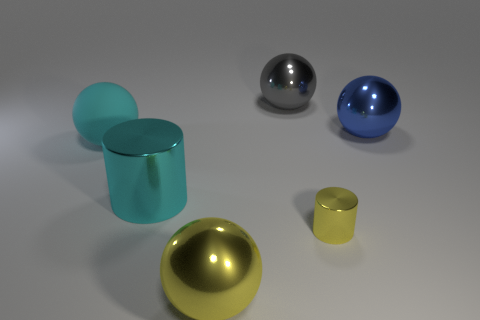Are there any other things that have the same size as the yellow cylinder?
Give a very brief answer. No. There is a metallic thing that is on the right side of the tiny yellow thing; does it have the same shape as the large cyan rubber object?
Offer a very short reply. Yes. Are there more cyan rubber things that are on the right side of the big yellow ball than small blue matte spheres?
Make the answer very short. No. There is a metallic cylinder to the left of the metallic sphere in front of the blue metallic sphere; what color is it?
Provide a succinct answer. Cyan. How many small yellow metal cylinders are there?
Your answer should be compact. 1. How many metallic balls are to the left of the tiny yellow cylinder and behind the yellow metal cylinder?
Your answer should be very brief. 1. Is there anything else that has the same shape as the blue shiny object?
Your response must be concise. Yes. There is a big rubber object; is it the same color as the cylinder that is right of the big yellow sphere?
Provide a short and direct response. No. There is a large yellow thing that is in front of the big cyan rubber sphere; what is its shape?
Your answer should be very brief. Sphere. What number of other objects are there of the same material as the blue ball?
Your answer should be compact. 4. 